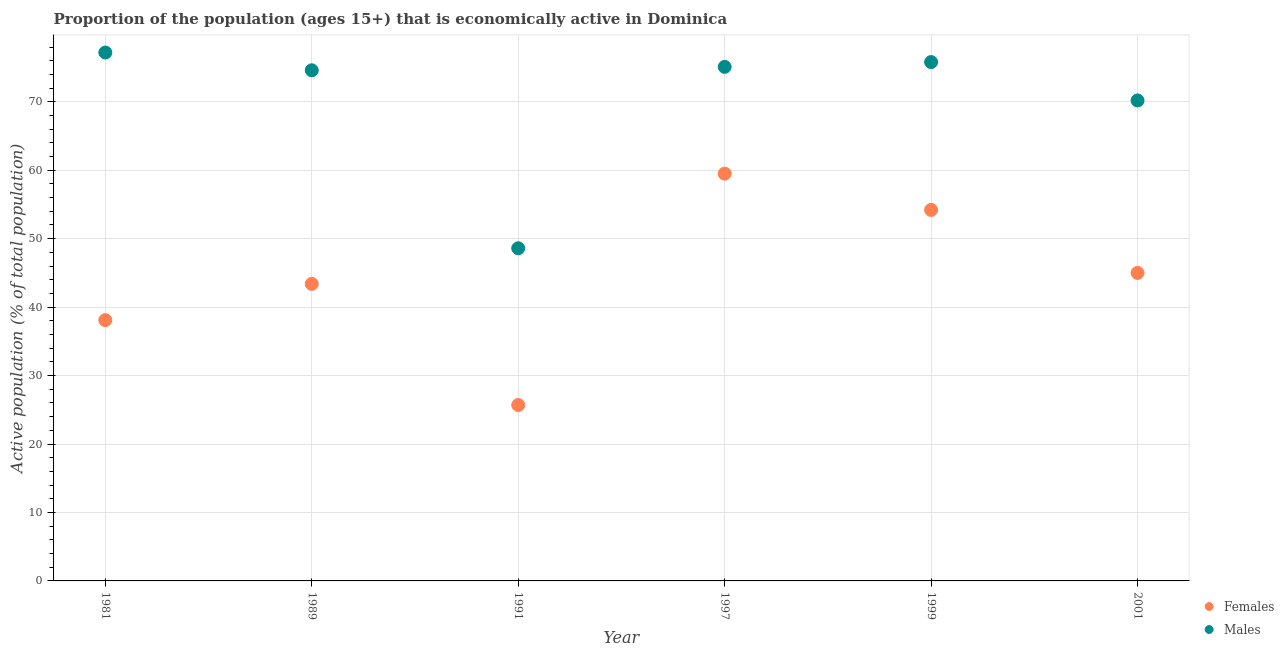What is the percentage of economically active female population in 1991?
Offer a terse response. 25.7. Across all years, what is the maximum percentage of economically active male population?
Keep it short and to the point. 77.2. Across all years, what is the minimum percentage of economically active male population?
Ensure brevity in your answer.  48.6. In which year was the percentage of economically active female population maximum?
Your answer should be compact. 1997. What is the total percentage of economically active male population in the graph?
Give a very brief answer. 421.5. What is the difference between the percentage of economically active male population in 1989 and that in 1991?
Keep it short and to the point. 26. What is the difference between the percentage of economically active male population in 1989 and the percentage of economically active female population in 1991?
Your answer should be very brief. 48.9. What is the average percentage of economically active female population per year?
Provide a short and direct response. 44.32. In the year 1991, what is the difference between the percentage of economically active female population and percentage of economically active male population?
Give a very brief answer. -22.9. In how many years, is the percentage of economically active female population greater than 30 %?
Provide a succinct answer. 5. What is the ratio of the percentage of economically active male population in 1981 to that in 1999?
Make the answer very short. 1.02. What is the difference between the highest and the second highest percentage of economically active male population?
Provide a succinct answer. 1.4. What is the difference between the highest and the lowest percentage of economically active female population?
Keep it short and to the point. 33.8. Is the sum of the percentage of economically active female population in 1997 and 2001 greater than the maximum percentage of economically active male population across all years?
Your response must be concise. Yes. Does the percentage of economically active female population monotonically increase over the years?
Offer a terse response. No. Is the percentage of economically active female population strictly greater than the percentage of economically active male population over the years?
Keep it short and to the point. No. Does the graph contain any zero values?
Your response must be concise. No. How many legend labels are there?
Provide a succinct answer. 2. How are the legend labels stacked?
Provide a succinct answer. Vertical. What is the title of the graph?
Your answer should be very brief. Proportion of the population (ages 15+) that is economically active in Dominica. What is the label or title of the Y-axis?
Provide a short and direct response. Active population (% of total population). What is the Active population (% of total population) in Females in 1981?
Provide a short and direct response. 38.1. What is the Active population (% of total population) in Males in 1981?
Ensure brevity in your answer.  77.2. What is the Active population (% of total population) of Females in 1989?
Offer a very short reply. 43.4. What is the Active population (% of total population) in Males in 1989?
Provide a short and direct response. 74.6. What is the Active population (% of total population) in Females in 1991?
Offer a very short reply. 25.7. What is the Active population (% of total population) in Males in 1991?
Offer a terse response. 48.6. What is the Active population (% of total population) in Females in 1997?
Offer a terse response. 59.5. What is the Active population (% of total population) of Males in 1997?
Provide a short and direct response. 75.1. What is the Active population (% of total population) in Females in 1999?
Offer a very short reply. 54.2. What is the Active population (% of total population) in Males in 1999?
Your answer should be very brief. 75.8. What is the Active population (% of total population) of Females in 2001?
Your answer should be compact. 45. What is the Active population (% of total population) of Males in 2001?
Offer a very short reply. 70.2. Across all years, what is the maximum Active population (% of total population) of Females?
Provide a short and direct response. 59.5. Across all years, what is the maximum Active population (% of total population) in Males?
Your answer should be very brief. 77.2. Across all years, what is the minimum Active population (% of total population) of Females?
Provide a short and direct response. 25.7. Across all years, what is the minimum Active population (% of total population) in Males?
Your answer should be very brief. 48.6. What is the total Active population (% of total population) of Females in the graph?
Provide a succinct answer. 265.9. What is the total Active population (% of total population) in Males in the graph?
Give a very brief answer. 421.5. What is the difference between the Active population (% of total population) in Females in 1981 and that in 1991?
Offer a very short reply. 12.4. What is the difference between the Active population (% of total population) of Males in 1981 and that in 1991?
Ensure brevity in your answer.  28.6. What is the difference between the Active population (% of total population) of Females in 1981 and that in 1997?
Provide a short and direct response. -21.4. What is the difference between the Active population (% of total population) in Females in 1981 and that in 1999?
Offer a very short reply. -16.1. What is the difference between the Active population (% of total population) in Females in 1989 and that in 1991?
Make the answer very short. 17.7. What is the difference between the Active population (% of total population) of Females in 1989 and that in 1997?
Provide a succinct answer. -16.1. What is the difference between the Active population (% of total population) of Males in 1989 and that in 1999?
Provide a succinct answer. -1.2. What is the difference between the Active population (% of total population) in Females in 1989 and that in 2001?
Your answer should be very brief. -1.6. What is the difference between the Active population (% of total population) of Females in 1991 and that in 1997?
Offer a very short reply. -33.8. What is the difference between the Active population (% of total population) in Males in 1991 and that in 1997?
Provide a succinct answer. -26.5. What is the difference between the Active population (% of total population) of Females in 1991 and that in 1999?
Give a very brief answer. -28.5. What is the difference between the Active population (% of total population) of Males in 1991 and that in 1999?
Ensure brevity in your answer.  -27.2. What is the difference between the Active population (% of total population) in Females in 1991 and that in 2001?
Your answer should be compact. -19.3. What is the difference between the Active population (% of total population) in Males in 1991 and that in 2001?
Offer a very short reply. -21.6. What is the difference between the Active population (% of total population) in Females in 1997 and that in 1999?
Your response must be concise. 5.3. What is the difference between the Active population (% of total population) of Females in 1999 and that in 2001?
Offer a terse response. 9.2. What is the difference between the Active population (% of total population) of Females in 1981 and the Active population (% of total population) of Males in 1989?
Offer a terse response. -36.5. What is the difference between the Active population (% of total population) in Females in 1981 and the Active population (% of total population) in Males in 1997?
Give a very brief answer. -37. What is the difference between the Active population (% of total population) in Females in 1981 and the Active population (% of total population) in Males in 1999?
Provide a succinct answer. -37.7. What is the difference between the Active population (% of total population) in Females in 1981 and the Active population (% of total population) in Males in 2001?
Keep it short and to the point. -32.1. What is the difference between the Active population (% of total population) in Females in 1989 and the Active population (% of total population) in Males in 1997?
Provide a succinct answer. -31.7. What is the difference between the Active population (% of total population) in Females in 1989 and the Active population (% of total population) in Males in 1999?
Provide a short and direct response. -32.4. What is the difference between the Active population (% of total population) in Females in 1989 and the Active population (% of total population) in Males in 2001?
Your response must be concise. -26.8. What is the difference between the Active population (% of total population) of Females in 1991 and the Active population (% of total population) of Males in 1997?
Offer a terse response. -49.4. What is the difference between the Active population (% of total population) of Females in 1991 and the Active population (% of total population) of Males in 1999?
Offer a very short reply. -50.1. What is the difference between the Active population (% of total population) of Females in 1991 and the Active population (% of total population) of Males in 2001?
Offer a terse response. -44.5. What is the difference between the Active population (% of total population) of Females in 1997 and the Active population (% of total population) of Males in 1999?
Give a very brief answer. -16.3. What is the average Active population (% of total population) of Females per year?
Give a very brief answer. 44.32. What is the average Active population (% of total population) of Males per year?
Ensure brevity in your answer.  70.25. In the year 1981, what is the difference between the Active population (% of total population) of Females and Active population (% of total population) of Males?
Provide a short and direct response. -39.1. In the year 1989, what is the difference between the Active population (% of total population) of Females and Active population (% of total population) of Males?
Give a very brief answer. -31.2. In the year 1991, what is the difference between the Active population (% of total population) of Females and Active population (% of total population) of Males?
Offer a very short reply. -22.9. In the year 1997, what is the difference between the Active population (% of total population) of Females and Active population (% of total population) of Males?
Keep it short and to the point. -15.6. In the year 1999, what is the difference between the Active population (% of total population) of Females and Active population (% of total population) of Males?
Offer a terse response. -21.6. In the year 2001, what is the difference between the Active population (% of total population) in Females and Active population (% of total population) in Males?
Your response must be concise. -25.2. What is the ratio of the Active population (% of total population) of Females in 1981 to that in 1989?
Your answer should be very brief. 0.88. What is the ratio of the Active population (% of total population) of Males in 1981 to that in 1989?
Ensure brevity in your answer.  1.03. What is the ratio of the Active population (% of total population) of Females in 1981 to that in 1991?
Make the answer very short. 1.48. What is the ratio of the Active population (% of total population) of Males in 1981 to that in 1991?
Offer a terse response. 1.59. What is the ratio of the Active population (% of total population) in Females in 1981 to that in 1997?
Your answer should be very brief. 0.64. What is the ratio of the Active population (% of total population) of Males in 1981 to that in 1997?
Give a very brief answer. 1.03. What is the ratio of the Active population (% of total population) of Females in 1981 to that in 1999?
Your answer should be very brief. 0.7. What is the ratio of the Active population (% of total population) of Males in 1981 to that in 1999?
Give a very brief answer. 1.02. What is the ratio of the Active population (% of total population) in Females in 1981 to that in 2001?
Provide a succinct answer. 0.85. What is the ratio of the Active population (% of total population) of Males in 1981 to that in 2001?
Provide a succinct answer. 1.1. What is the ratio of the Active population (% of total population) in Females in 1989 to that in 1991?
Your response must be concise. 1.69. What is the ratio of the Active population (% of total population) of Males in 1989 to that in 1991?
Your answer should be compact. 1.53. What is the ratio of the Active population (% of total population) in Females in 1989 to that in 1997?
Provide a succinct answer. 0.73. What is the ratio of the Active population (% of total population) of Females in 1989 to that in 1999?
Offer a terse response. 0.8. What is the ratio of the Active population (% of total population) of Males in 1989 to that in 1999?
Keep it short and to the point. 0.98. What is the ratio of the Active population (% of total population) in Females in 1989 to that in 2001?
Your answer should be very brief. 0.96. What is the ratio of the Active population (% of total population) of Males in 1989 to that in 2001?
Offer a terse response. 1.06. What is the ratio of the Active population (% of total population) of Females in 1991 to that in 1997?
Your answer should be very brief. 0.43. What is the ratio of the Active population (% of total population) of Males in 1991 to that in 1997?
Offer a terse response. 0.65. What is the ratio of the Active population (% of total population) in Females in 1991 to that in 1999?
Your answer should be very brief. 0.47. What is the ratio of the Active population (% of total population) in Males in 1991 to that in 1999?
Your answer should be very brief. 0.64. What is the ratio of the Active population (% of total population) in Females in 1991 to that in 2001?
Keep it short and to the point. 0.57. What is the ratio of the Active population (% of total population) of Males in 1991 to that in 2001?
Provide a succinct answer. 0.69. What is the ratio of the Active population (% of total population) in Females in 1997 to that in 1999?
Ensure brevity in your answer.  1.1. What is the ratio of the Active population (% of total population) in Males in 1997 to that in 1999?
Your response must be concise. 0.99. What is the ratio of the Active population (% of total population) of Females in 1997 to that in 2001?
Provide a succinct answer. 1.32. What is the ratio of the Active population (% of total population) in Males in 1997 to that in 2001?
Provide a succinct answer. 1.07. What is the ratio of the Active population (% of total population) of Females in 1999 to that in 2001?
Your answer should be very brief. 1.2. What is the ratio of the Active population (% of total population) of Males in 1999 to that in 2001?
Your answer should be very brief. 1.08. What is the difference between the highest and the lowest Active population (% of total population) in Females?
Your response must be concise. 33.8. What is the difference between the highest and the lowest Active population (% of total population) of Males?
Your answer should be very brief. 28.6. 